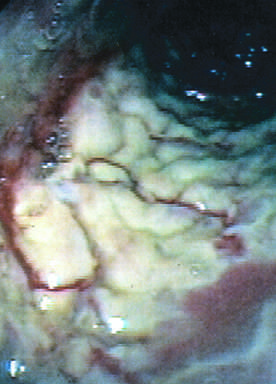what is the colon coated by?
Answer the question using a single word or phrase. Tan pseudomembranes 